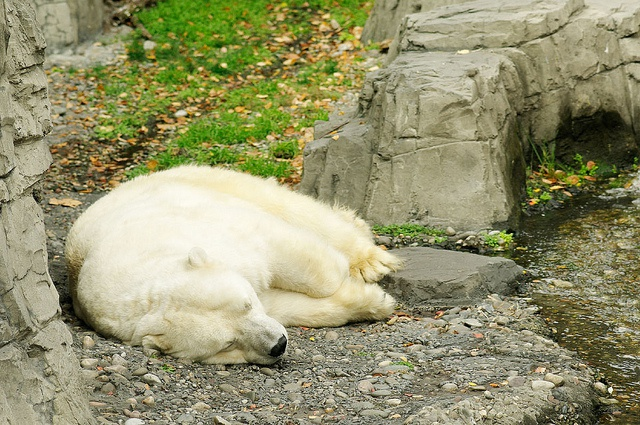Describe the objects in this image and their specific colors. I can see a bear in gray, beige, and tan tones in this image. 